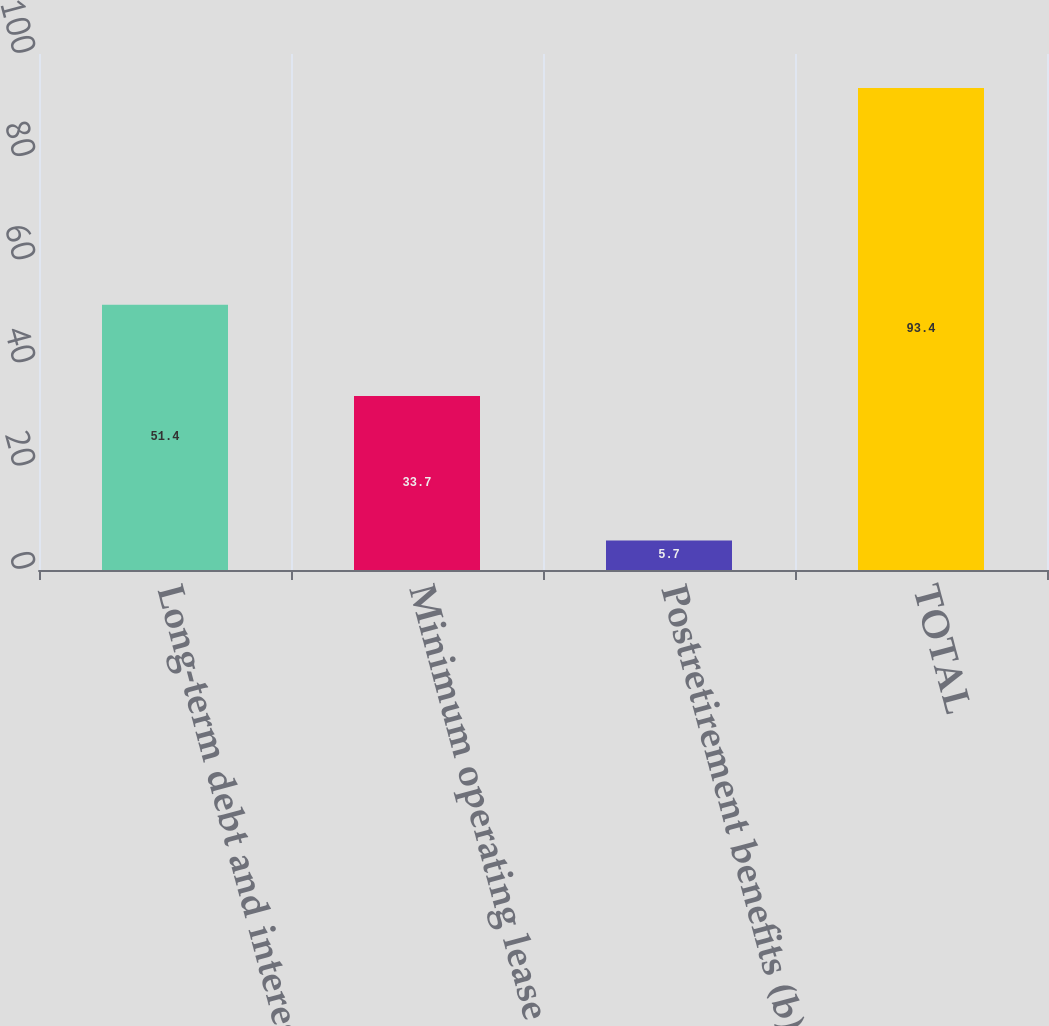Convert chart to OTSL. <chart><loc_0><loc_0><loc_500><loc_500><bar_chart><fcel>Long-term debt and interest<fcel>Minimum operating lease<fcel>Postretirement benefits (b)<fcel>TOTAL<nl><fcel>51.4<fcel>33.7<fcel>5.7<fcel>93.4<nl></chart> 